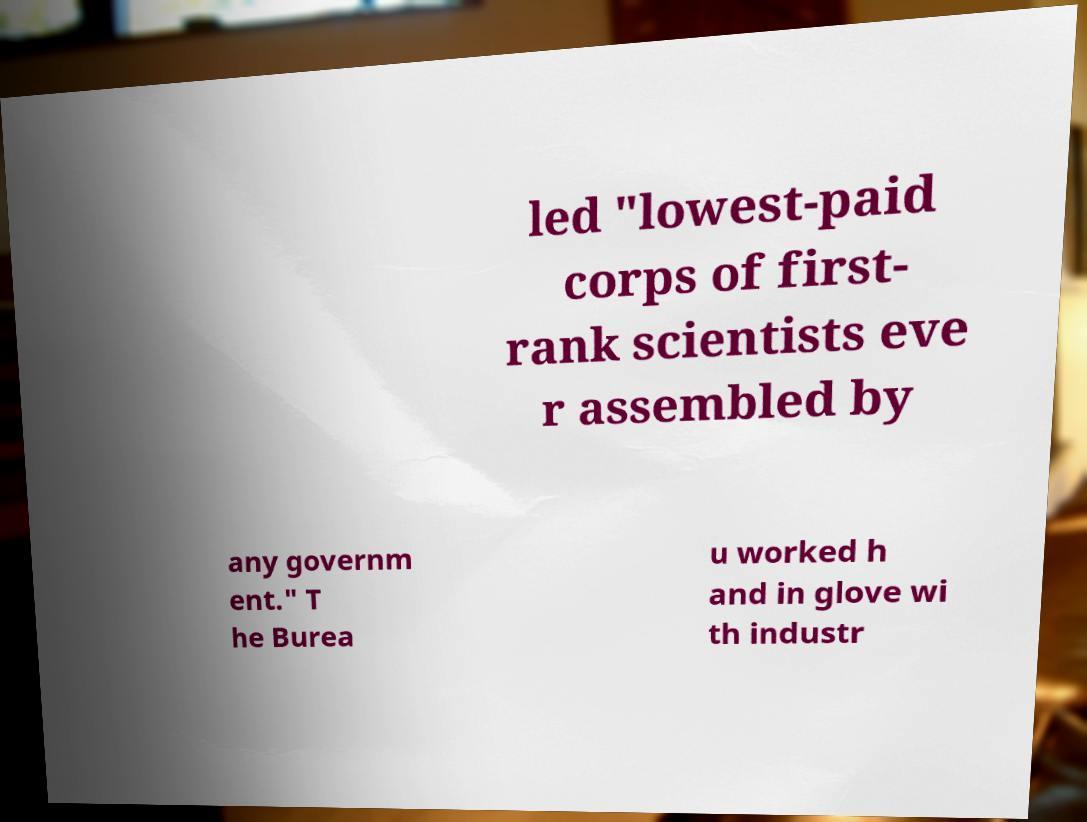Can you accurately transcribe the text from the provided image for me? led "lowest-paid corps of first- rank scientists eve r assembled by any governm ent." T he Burea u worked h and in glove wi th industr 